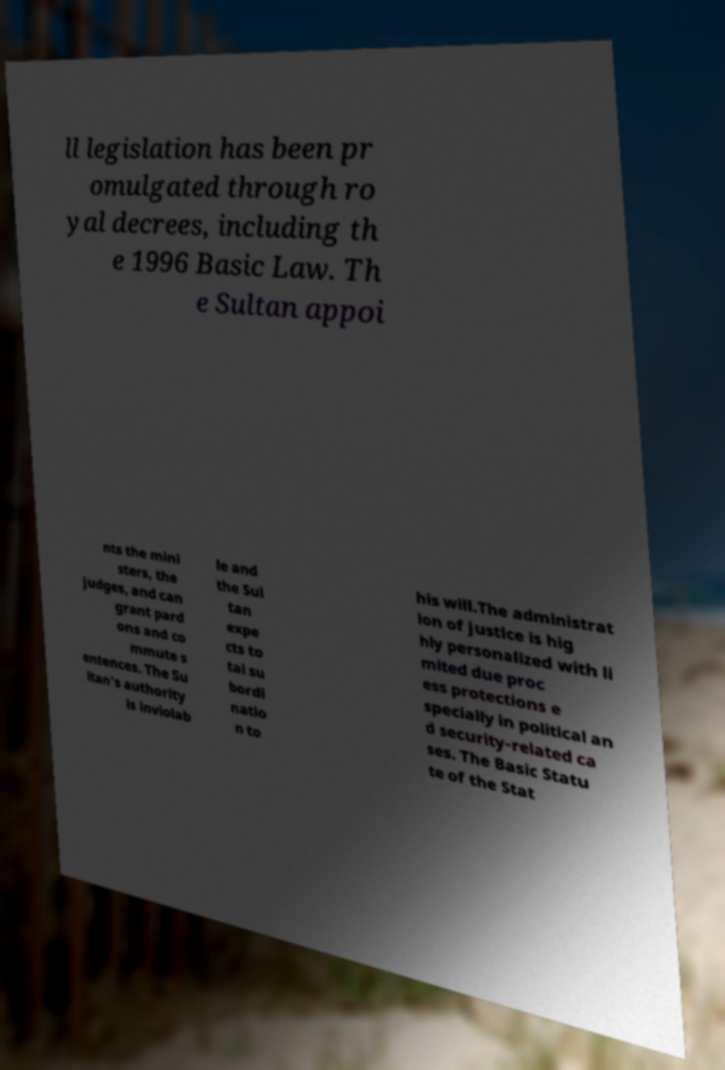Could you assist in decoding the text presented in this image and type it out clearly? ll legislation has been pr omulgated through ro yal decrees, including th e 1996 Basic Law. Th e Sultan appoi nts the mini sters, the judges, and can grant pard ons and co mmute s entences. The Su ltan's authority is inviolab le and the Sul tan expe cts to tal su bordi natio n to his will.The administrat ion of justice is hig hly personalized with li mited due proc ess protections e specially in political an d security-related ca ses. The Basic Statu te of the Stat 